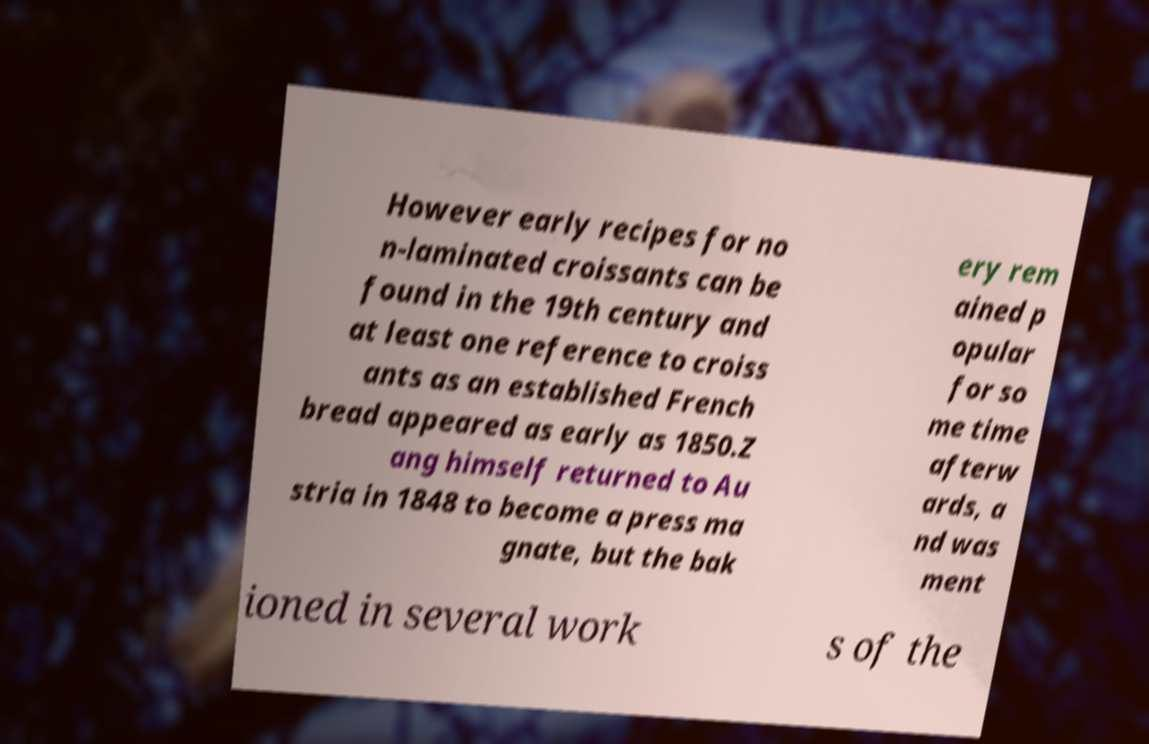Please read and relay the text visible in this image. What does it say? However early recipes for no n-laminated croissants can be found in the 19th century and at least one reference to croiss ants as an established French bread appeared as early as 1850.Z ang himself returned to Au stria in 1848 to become a press ma gnate, but the bak ery rem ained p opular for so me time afterw ards, a nd was ment ioned in several work s of the 